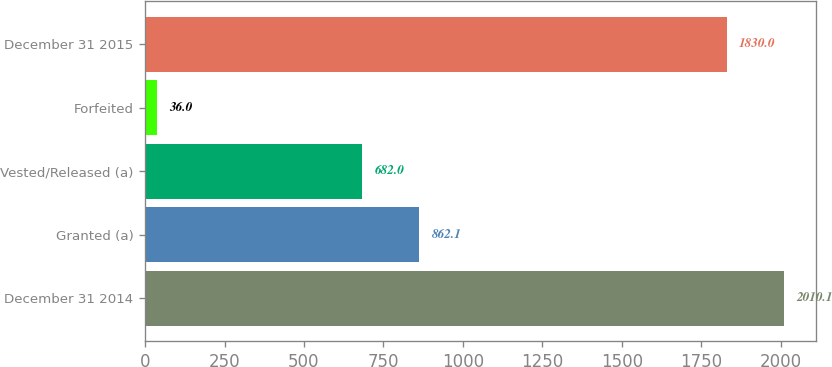<chart> <loc_0><loc_0><loc_500><loc_500><bar_chart><fcel>December 31 2014<fcel>Granted (a)<fcel>Vested/Released (a)<fcel>Forfeited<fcel>December 31 2015<nl><fcel>2010.1<fcel>862.1<fcel>682<fcel>36<fcel>1830<nl></chart> 